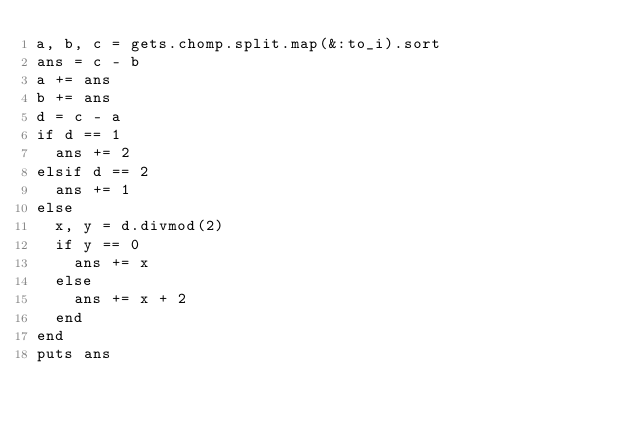Convert code to text. <code><loc_0><loc_0><loc_500><loc_500><_Ruby_>a, b, c = gets.chomp.split.map(&:to_i).sort
ans = c - b
a += ans
b += ans
d = c - a
if d == 1
  ans += 2
elsif d == 2
  ans += 1
else
  x, y = d.divmod(2)
  if y == 0
    ans += x
  else
    ans += x + 2
  end
end
puts ans</code> 